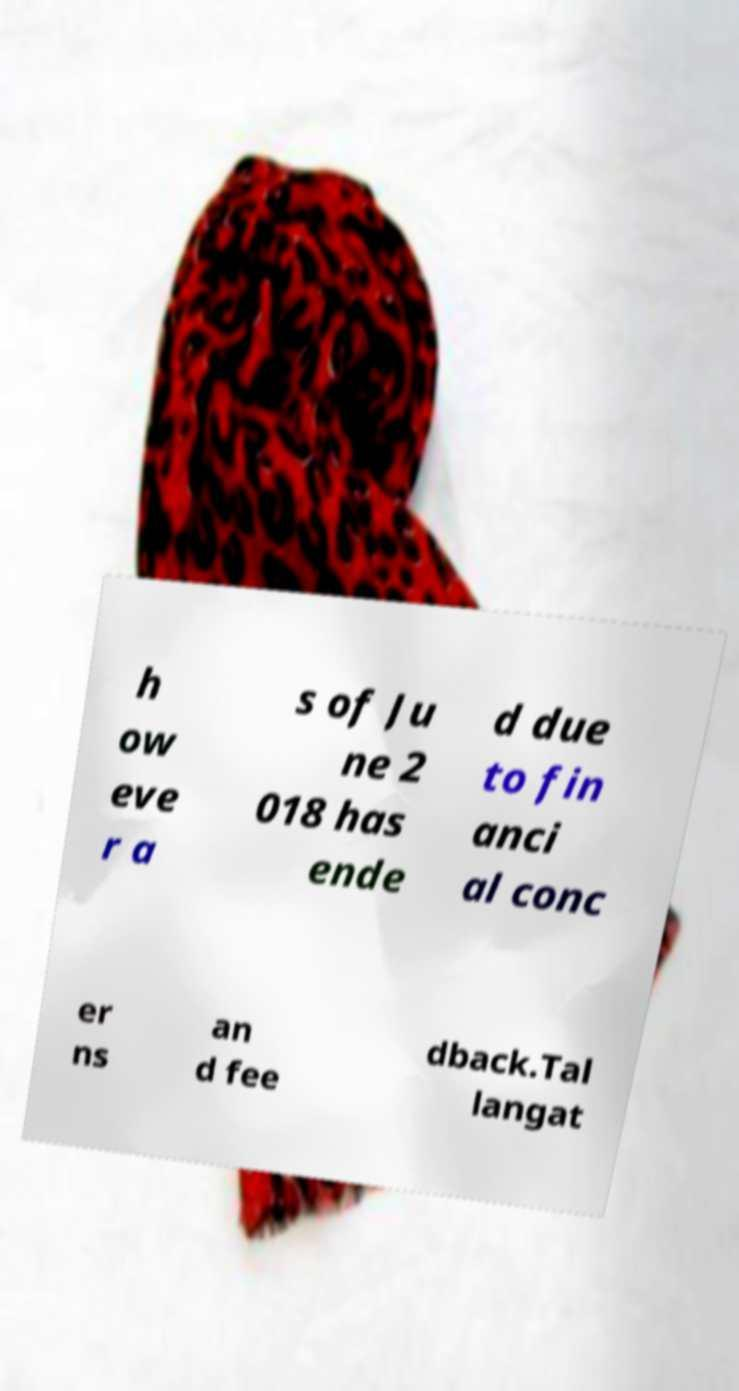There's text embedded in this image that I need extracted. Can you transcribe it verbatim? h ow eve r a s of Ju ne 2 018 has ende d due to fin anci al conc er ns an d fee dback.Tal langat 